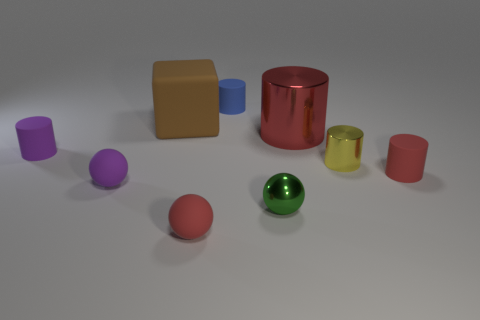Subtract all cyan spheres. How many red cylinders are left? 2 Subtract all small matte spheres. How many spheres are left? 1 Subtract all blue cylinders. How many cylinders are left? 4 Subtract all cylinders. How many objects are left? 4 Subtract 1 spheres. How many spheres are left? 2 Add 1 tiny yellow objects. How many tiny yellow objects are left? 2 Add 1 red cylinders. How many red cylinders exist? 3 Subtract 1 red spheres. How many objects are left? 8 Subtract all red balls. Subtract all purple cylinders. How many balls are left? 2 Subtract all small red rubber balls. Subtract all metal spheres. How many objects are left? 7 